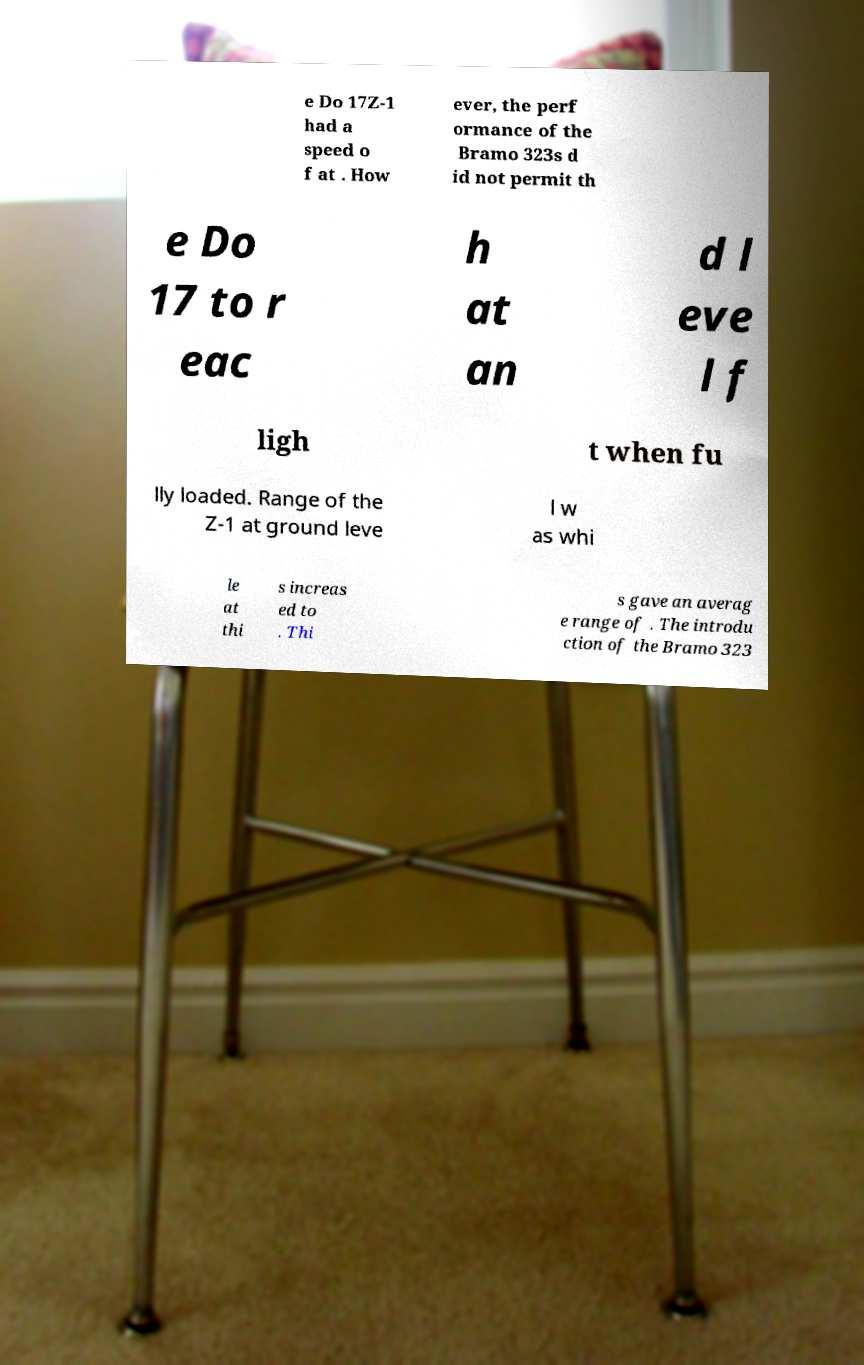Please read and relay the text visible in this image. What does it say? e Do 17Z-1 had a speed o f at . How ever, the perf ormance of the Bramo 323s d id not permit th e Do 17 to r eac h at an d l eve l f ligh t when fu lly loaded. Range of the Z-1 at ground leve l w as whi le at thi s increas ed to . Thi s gave an averag e range of . The introdu ction of the Bramo 323 